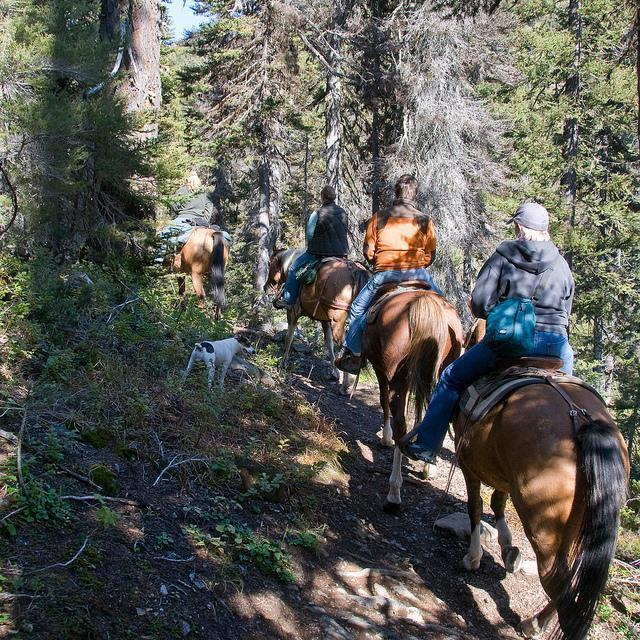How many horses are visible?
Give a very brief answer. 4. How many people are there?
Give a very brief answer. 3. 